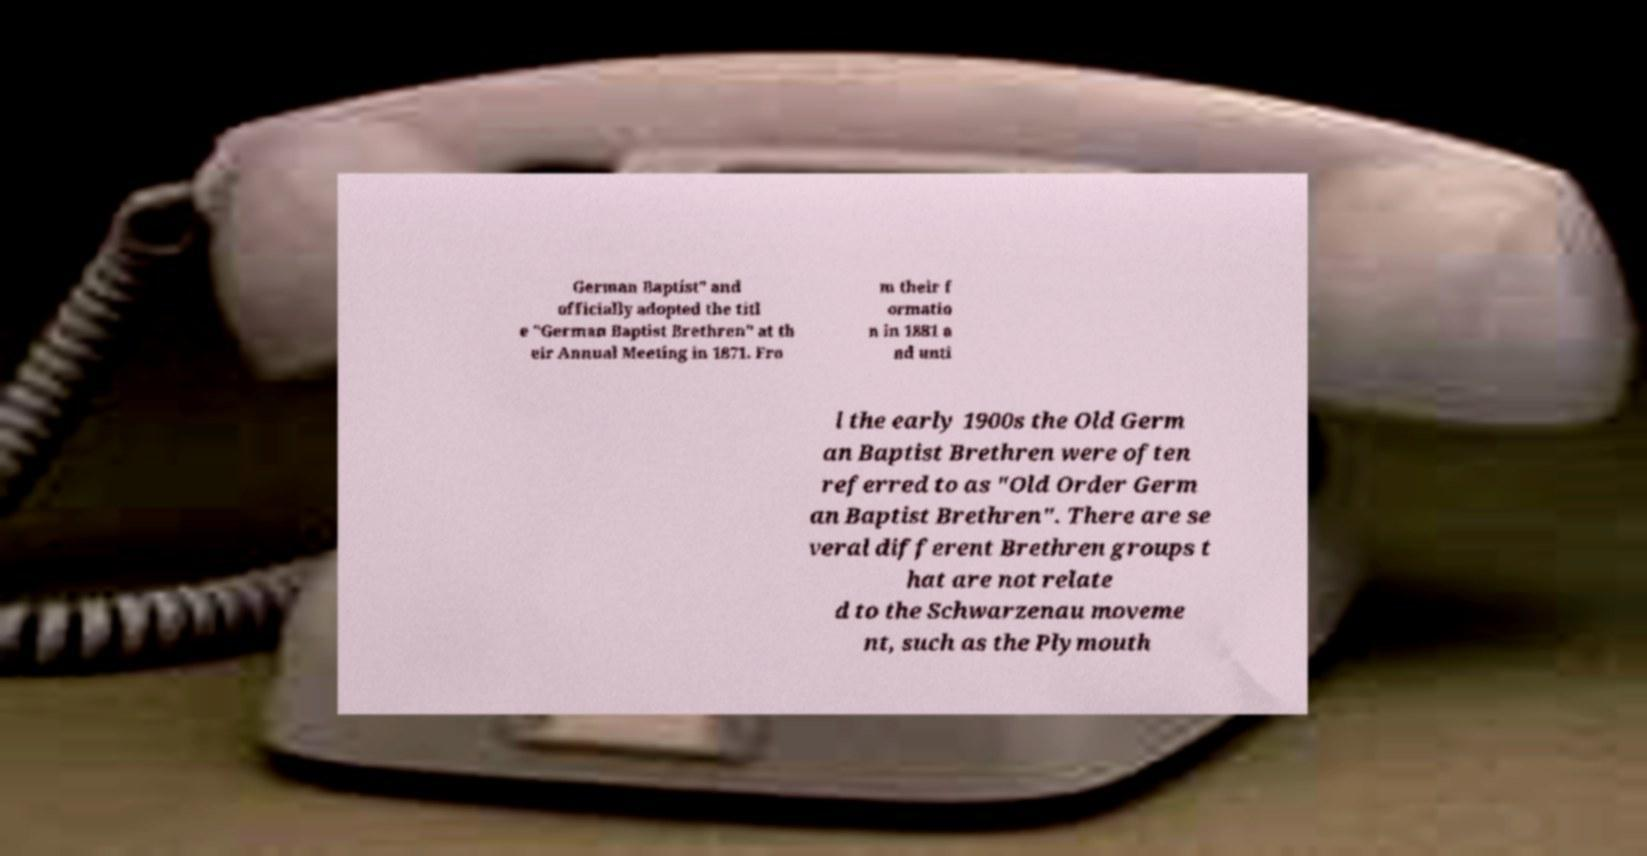What messages or text are displayed in this image? I need them in a readable, typed format. German Baptist" and officially adopted the titl e "German Baptist Brethren" at th eir Annual Meeting in 1871. Fro m their f ormatio n in 1881 a nd unti l the early 1900s the Old Germ an Baptist Brethren were often referred to as "Old Order Germ an Baptist Brethren". There are se veral different Brethren groups t hat are not relate d to the Schwarzenau moveme nt, such as the Plymouth 